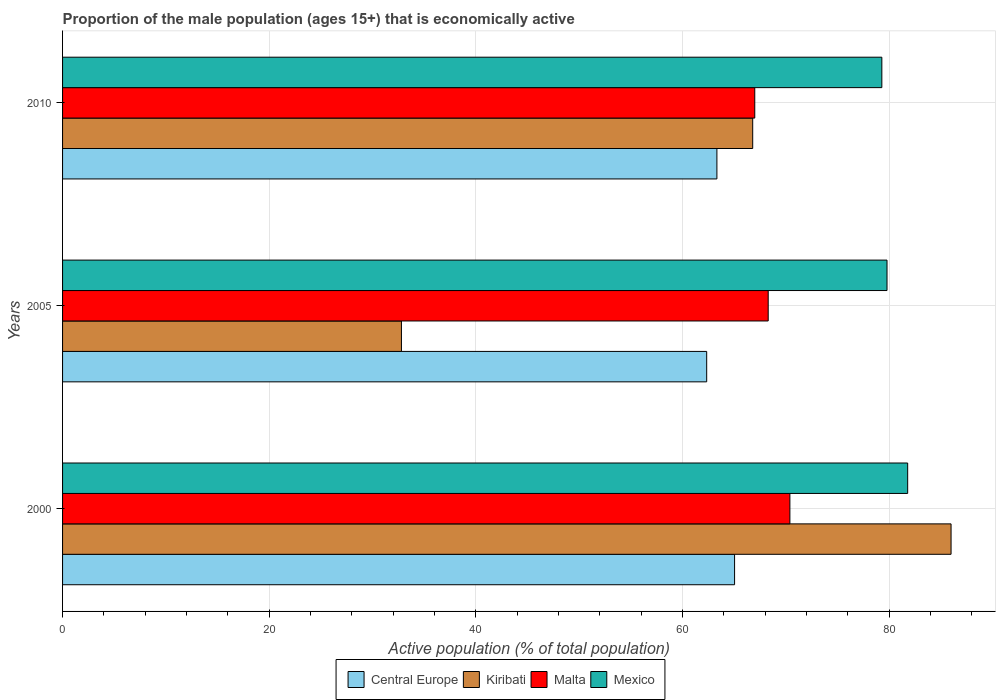Are the number of bars per tick equal to the number of legend labels?
Your answer should be very brief. Yes. Are the number of bars on each tick of the Y-axis equal?
Make the answer very short. Yes. How many bars are there on the 2nd tick from the bottom?
Your answer should be very brief. 4. In how many cases, is the number of bars for a given year not equal to the number of legend labels?
Give a very brief answer. 0. What is the proportion of the male population that is economically active in Central Europe in 2000?
Provide a succinct answer. 65.05. Across all years, what is the maximum proportion of the male population that is economically active in Mexico?
Offer a very short reply. 81.8. Across all years, what is the minimum proportion of the male population that is economically active in Central Europe?
Provide a succinct answer. 62.35. In which year was the proportion of the male population that is economically active in Central Europe maximum?
Your answer should be compact. 2000. What is the total proportion of the male population that is economically active in Kiribati in the graph?
Your answer should be compact. 185.6. What is the difference between the proportion of the male population that is economically active in Mexico in 2000 and that in 2005?
Make the answer very short. 2. What is the difference between the proportion of the male population that is economically active in Mexico in 2005 and the proportion of the male population that is economically active in Malta in 2000?
Your response must be concise. 9.4. What is the average proportion of the male population that is economically active in Mexico per year?
Your answer should be compact. 80.3. In the year 2005, what is the difference between the proportion of the male population that is economically active in Central Europe and proportion of the male population that is economically active in Kiribati?
Your answer should be compact. 29.55. In how many years, is the proportion of the male population that is economically active in Mexico greater than 52 %?
Give a very brief answer. 3. What is the ratio of the proportion of the male population that is economically active in Kiribati in 2005 to that in 2010?
Offer a very short reply. 0.49. Is the proportion of the male population that is economically active in Central Europe in 2000 less than that in 2005?
Your answer should be very brief. No. What is the difference between the highest and the second highest proportion of the male population that is economically active in Kiribati?
Ensure brevity in your answer.  19.2. What is the difference between the highest and the lowest proportion of the male population that is economically active in Kiribati?
Provide a succinct answer. 53.2. In how many years, is the proportion of the male population that is economically active in Kiribati greater than the average proportion of the male population that is economically active in Kiribati taken over all years?
Offer a very short reply. 2. Is it the case that in every year, the sum of the proportion of the male population that is economically active in Central Europe and proportion of the male population that is economically active in Malta is greater than the sum of proportion of the male population that is economically active in Kiribati and proportion of the male population that is economically active in Mexico?
Keep it short and to the point. Yes. What does the 2nd bar from the top in 2005 represents?
Give a very brief answer. Malta. What does the 3rd bar from the bottom in 2000 represents?
Your answer should be compact. Malta. Is it the case that in every year, the sum of the proportion of the male population that is economically active in Mexico and proportion of the male population that is economically active in Central Europe is greater than the proportion of the male population that is economically active in Kiribati?
Your answer should be very brief. Yes. Are all the bars in the graph horizontal?
Your answer should be compact. Yes. Are the values on the major ticks of X-axis written in scientific E-notation?
Provide a succinct answer. No. Does the graph contain any zero values?
Make the answer very short. No. Where does the legend appear in the graph?
Give a very brief answer. Bottom center. How many legend labels are there?
Make the answer very short. 4. How are the legend labels stacked?
Provide a short and direct response. Horizontal. What is the title of the graph?
Your answer should be very brief. Proportion of the male population (ages 15+) that is economically active. Does "Yemen, Rep." appear as one of the legend labels in the graph?
Your response must be concise. No. What is the label or title of the X-axis?
Your answer should be compact. Active population (% of total population). What is the label or title of the Y-axis?
Ensure brevity in your answer.  Years. What is the Active population (% of total population) in Central Europe in 2000?
Provide a succinct answer. 65.05. What is the Active population (% of total population) in Kiribati in 2000?
Ensure brevity in your answer.  86. What is the Active population (% of total population) in Malta in 2000?
Offer a very short reply. 70.4. What is the Active population (% of total population) in Mexico in 2000?
Ensure brevity in your answer.  81.8. What is the Active population (% of total population) of Central Europe in 2005?
Provide a short and direct response. 62.35. What is the Active population (% of total population) of Kiribati in 2005?
Offer a very short reply. 32.8. What is the Active population (% of total population) of Malta in 2005?
Your answer should be very brief. 68.3. What is the Active population (% of total population) in Mexico in 2005?
Your response must be concise. 79.8. What is the Active population (% of total population) in Central Europe in 2010?
Your response must be concise. 63.33. What is the Active population (% of total population) of Kiribati in 2010?
Offer a very short reply. 66.8. What is the Active population (% of total population) of Malta in 2010?
Offer a terse response. 67. What is the Active population (% of total population) of Mexico in 2010?
Keep it short and to the point. 79.3. Across all years, what is the maximum Active population (% of total population) in Central Europe?
Offer a terse response. 65.05. Across all years, what is the maximum Active population (% of total population) in Kiribati?
Offer a terse response. 86. Across all years, what is the maximum Active population (% of total population) of Malta?
Offer a terse response. 70.4. Across all years, what is the maximum Active population (% of total population) in Mexico?
Make the answer very short. 81.8. Across all years, what is the minimum Active population (% of total population) in Central Europe?
Provide a succinct answer. 62.35. Across all years, what is the minimum Active population (% of total population) in Kiribati?
Offer a very short reply. 32.8. Across all years, what is the minimum Active population (% of total population) in Malta?
Provide a short and direct response. 67. Across all years, what is the minimum Active population (% of total population) of Mexico?
Make the answer very short. 79.3. What is the total Active population (% of total population) in Central Europe in the graph?
Make the answer very short. 190.73. What is the total Active population (% of total population) of Kiribati in the graph?
Your response must be concise. 185.6. What is the total Active population (% of total population) of Malta in the graph?
Your response must be concise. 205.7. What is the total Active population (% of total population) of Mexico in the graph?
Ensure brevity in your answer.  240.9. What is the difference between the Active population (% of total population) in Central Europe in 2000 and that in 2005?
Offer a terse response. 2.7. What is the difference between the Active population (% of total population) of Kiribati in 2000 and that in 2005?
Provide a short and direct response. 53.2. What is the difference between the Active population (% of total population) of Malta in 2000 and that in 2005?
Your answer should be very brief. 2.1. What is the difference between the Active population (% of total population) of Central Europe in 2000 and that in 2010?
Offer a terse response. 1.71. What is the difference between the Active population (% of total population) in Malta in 2000 and that in 2010?
Offer a terse response. 3.4. What is the difference between the Active population (% of total population) of Central Europe in 2005 and that in 2010?
Provide a succinct answer. -0.99. What is the difference between the Active population (% of total population) of Kiribati in 2005 and that in 2010?
Offer a very short reply. -34. What is the difference between the Active population (% of total population) in Mexico in 2005 and that in 2010?
Your response must be concise. 0.5. What is the difference between the Active population (% of total population) of Central Europe in 2000 and the Active population (% of total population) of Kiribati in 2005?
Offer a very short reply. 32.25. What is the difference between the Active population (% of total population) of Central Europe in 2000 and the Active population (% of total population) of Malta in 2005?
Your answer should be compact. -3.25. What is the difference between the Active population (% of total population) in Central Europe in 2000 and the Active population (% of total population) in Mexico in 2005?
Offer a terse response. -14.75. What is the difference between the Active population (% of total population) in Central Europe in 2000 and the Active population (% of total population) in Kiribati in 2010?
Give a very brief answer. -1.75. What is the difference between the Active population (% of total population) in Central Europe in 2000 and the Active population (% of total population) in Malta in 2010?
Offer a terse response. -1.95. What is the difference between the Active population (% of total population) in Central Europe in 2000 and the Active population (% of total population) in Mexico in 2010?
Your response must be concise. -14.25. What is the difference between the Active population (% of total population) in Kiribati in 2000 and the Active population (% of total population) in Malta in 2010?
Your answer should be very brief. 19. What is the difference between the Active population (% of total population) in Malta in 2000 and the Active population (% of total population) in Mexico in 2010?
Keep it short and to the point. -8.9. What is the difference between the Active population (% of total population) in Central Europe in 2005 and the Active population (% of total population) in Kiribati in 2010?
Offer a very short reply. -4.45. What is the difference between the Active population (% of total population) of Central Europe in 2005 and the Active population (% of total population) of Malta in 2010?
Your answer should be very brief. -4.65. What is the difference between the Active population (% of total population) of Central Europe in 2005 and the Active population (% of total population) of Mexico in 2010?
Offer a very short reply. -16.95. What is the difference between the Active population (% of total population) of Kiribati in 2005 and the Active population (% of total population) of Malta in 2010?
Your answer should be compact. -34.2. What is the difference between the Active population (% of total population) in Kiribati in 2005 and the Active population (% of total population) in Mexico in 2010?
Make the answer very short. -46.5. What is the difference between the Active population (% of total population) in Malta in 2005 and the Active population (% of total population) in Mexico in 2010?
Keep it short and to the point. -11. What is the average Active population (% of total population) in Central Europe per year?
Offer a very short reply. 63.58. What is the average Active population (% of total population) in Kiribati per year?
Offer a terse response. 61.87. What is the average Active population (% of total population) in Malta per year?
Your answer should be compact. 68.57. What is the average Active population (% of total population) of Mexico per year?
Provide a short and direct response. 80.3. In the year 2000, what is the difference between the Active population (% of total population) of Central Europe and Active population (% of total population) of Kiribati?
Your answer should be very brief. -20.95. In the year 2000, what is the difference between the Active population (% of total population) in Central Europe and Active population (% of total population) in Malta?
Keep it short and to the point. -5.35. In the year 2000, what is the difference between the Active population (% of total population) in Central Europe and Active population (% of total population) in Mexico?
Provide a succinct answer. -16.75. In the year 2000, what is the difference between the Active population (% of total population) of Kiribati and Active population (% of total population) of Malta?
Ensure brevity in your answer.  15.6. In the year 2005, what is the difference between the Active population (% of total population) in Central Europe and Active population (% of total population) in Kiribati?
Ensure brevity in your answer.  29.55. In the year 2005, what is the difference between the Active population (% of total population) of Central Europe and Active population (% of total population) of Malta?
Your response must be concise. -5.95. In the year 2005, what is the difference between the Active population (% of total population) of Central Europe and Active population (% of total population) of Mexico?
Keep it short and to the point. -17.45. In the year 2005, what is the difference between the Active population (% of total population) in Kiribati and Active population (% of total population) in Malta?
Your answer should be compact. -35.5. In the year 2005, what is the difference between the Active population (% of total population) in Kiribati and Active population (% of total population) in Mexico?
Your answer should be compact. -47. In the year 2005, what is the difference between the Active population (% of total population) of Malta and Active population (% of total population) of Mexico?
Offer a terse response. -11.5. In the year 2010, what is the difference between the Active population (% of total population) in Central Europe and Active population (% of total population) in Kiribati?
Keep it short and to the point. -3.47. In the year 2010, what is the difference between the Active population (% of total population) of Central Europe and Active population (% of total population) of Malta?
Offer a terse response. -3.67. In the year 2010, what is the difference between the Active population (% of total population) in Central Europe and Active population (% of total population) in Mexico?
Make the answer very short. -15.97. In the year 2010, what is the difference between the Active population (% of total population) in Kiribati and Active population (% of total population) in Malta?
Make the answer very short. -0.2. What is the ratio of the Active population (% of total population) in Central Europe in 2000 to that in 2005?
Ensure brevity in your answer.  1.04. What is the ratio of the Active population (% of total population) of Kiribati in 2000 to that in 2005?
Give a very brief answer. 2.62. What is the ratio of the Active population (% of total population) of Malta in 2000 to that in 2005?
Provide a succinct answer. 1.03. What is the ratio of the Active population (% of total population) of Mexico in 2000 to that in 2005?
Offer a terse response. 1.03. What is the ratio of the Active population (% of total population) in Central Europe in 2000 to that in 2010?
Provide a short and direct response. 1.03. What is the ratio of the Active population (% of total population) in Kiribati in 2000 to that in 2010?
Your answer should be compact. 1.29. What is the ratio of the Active population (% of total population) in Malta in 2000 to that in 2010?
Your answer should be compact. 1.05. What is the ratio of the Active population (% of total population) in Mexico in 2000 to that in 2010?
Give a very brief answer. 1.03. What is the ratio of the Active population (% of total population) in Central Europe in 2005 to that in 2010?
Your answer should be very brief. 0.98. What is the ratio of the Active population (% of total population) of Kiribati in 2005 to that in 2010?
Provide a succinct answer. 0.49. What is the ratio of the Active population (% of total population) of Malta in 2005 to that in 2010?
Your answer should be very brief. 1.02. What is the difference between the highest and the second highest Active population (% of total population) in Central Europe?
Give a very brief answer. 1.71. What is the difference between the highest and the second highest Active population (% of total population) in Kiribati?
Your answer should be very brief. 19.2. What is the difference between the highest and the second highest Active population (% of total population) in Malta?
Provide a short and direct response. 2.1. What is the difference between the highest and the lowest Active population (% of total population) of Central Europe?
Offer a very short reply. 2.7. What is the difference between the highest and the lowest Active population (% of total population) of Kiribati?
Ensure brevity in your answer.  53.2. What is the difference between the highest and the lowest Active population (% of total population) of Mexico?
Provide a short and direct response. 2.5. 